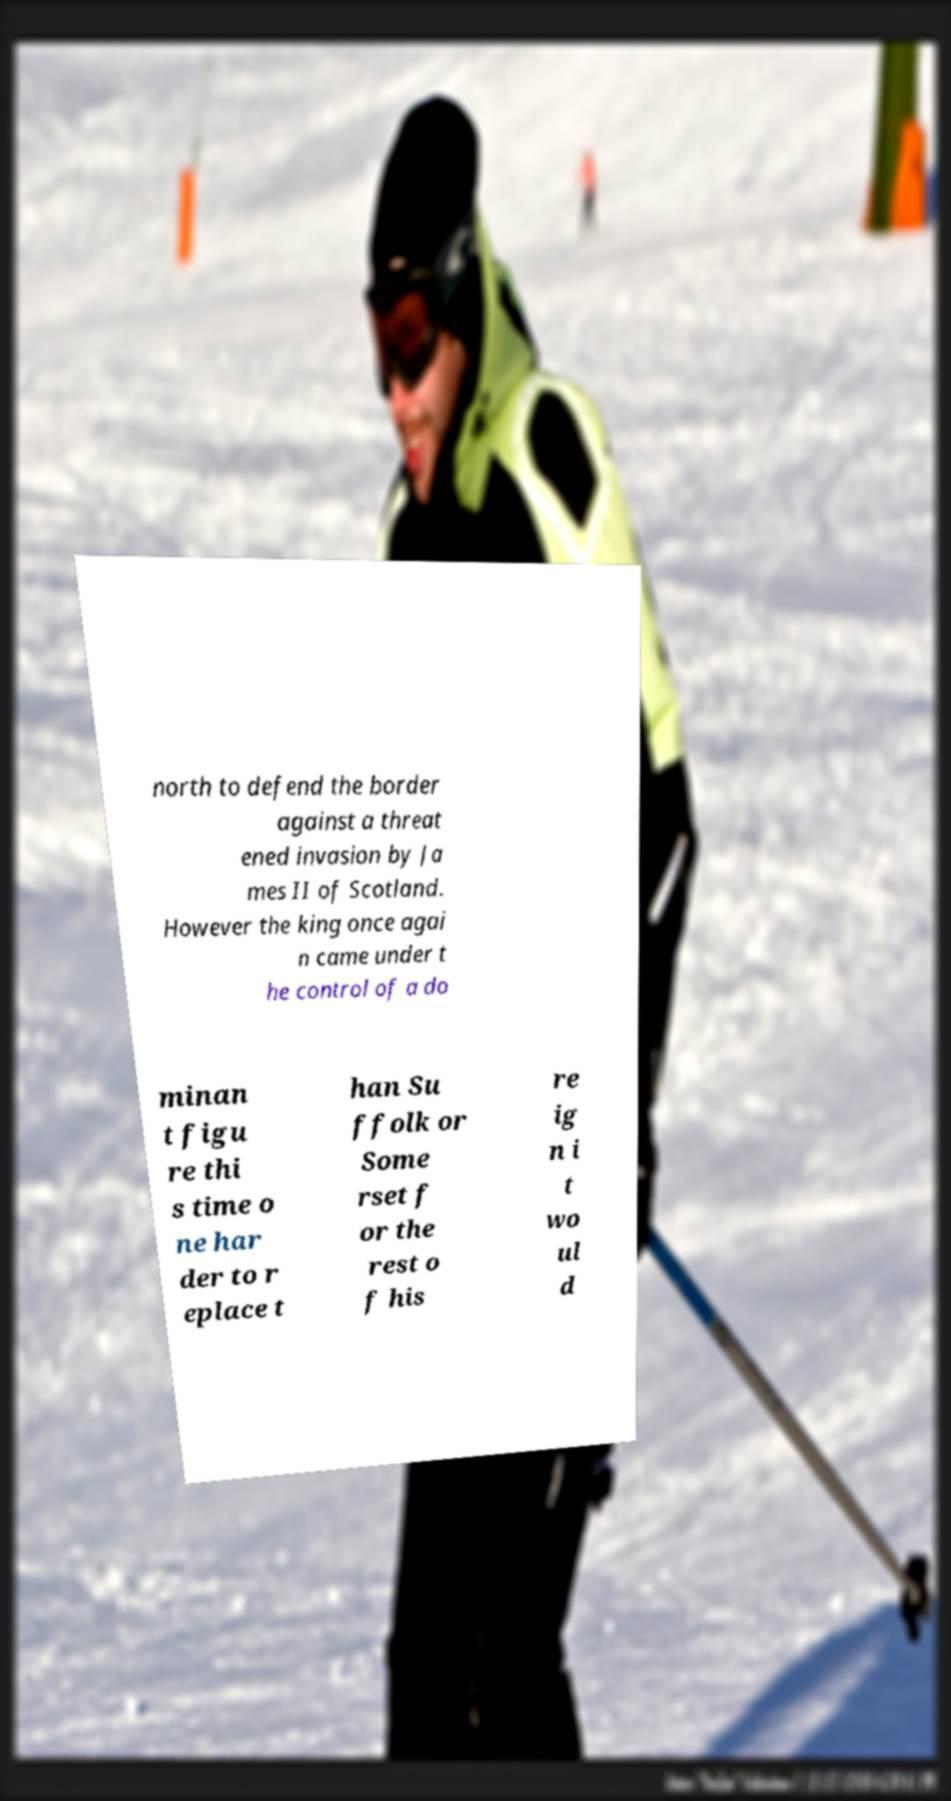I need the written content from this picture converted into text. Can you do that? north to defend the border against a threat ened invasion by Ja mes II of Scotland. However the king once agai n came under t he control of a do minan t figu re thi s time o ne har der to r eplace t han Su ffolk or Some rset f or the rest o f his re ig n i t wo ul d 